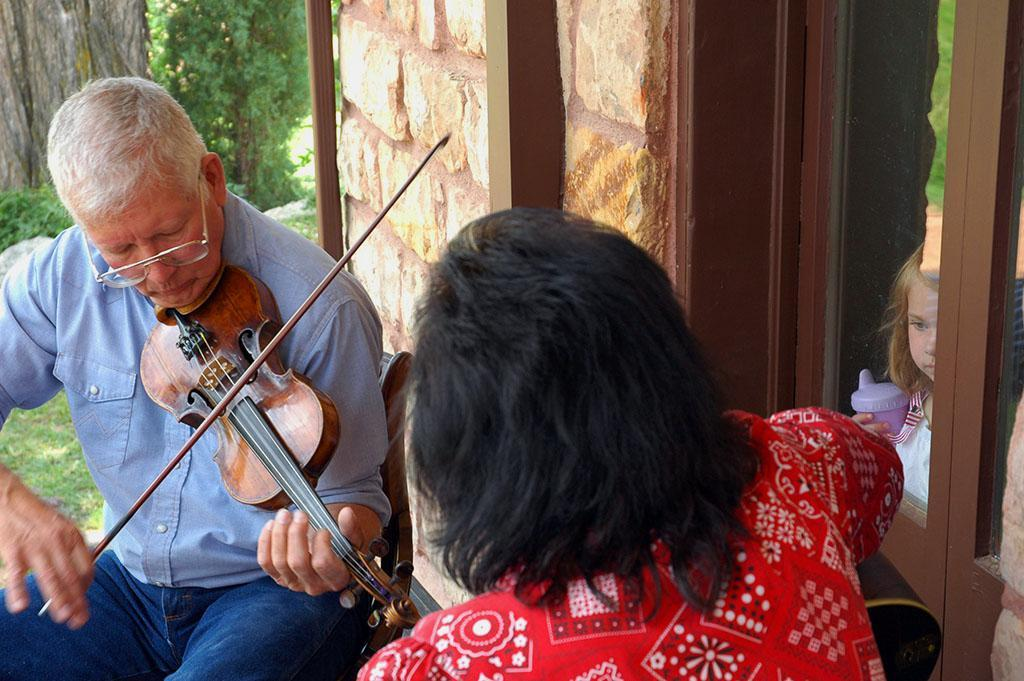What is: What is the man in the image doing? The man is playing the violin in the image. Who is present in the image besides the man playing the violin? There is a woman observing the man and a small kid in the image. What can be seen in the background of the image? There is a glass window in the background of the image. What type of mint is being used as a prop by the man playing the violin in the image? There is no mint present in the image, and the man is not using any props while playing the violin. How many rabbits can be seen in the image? There are no rabbits present in the image. 